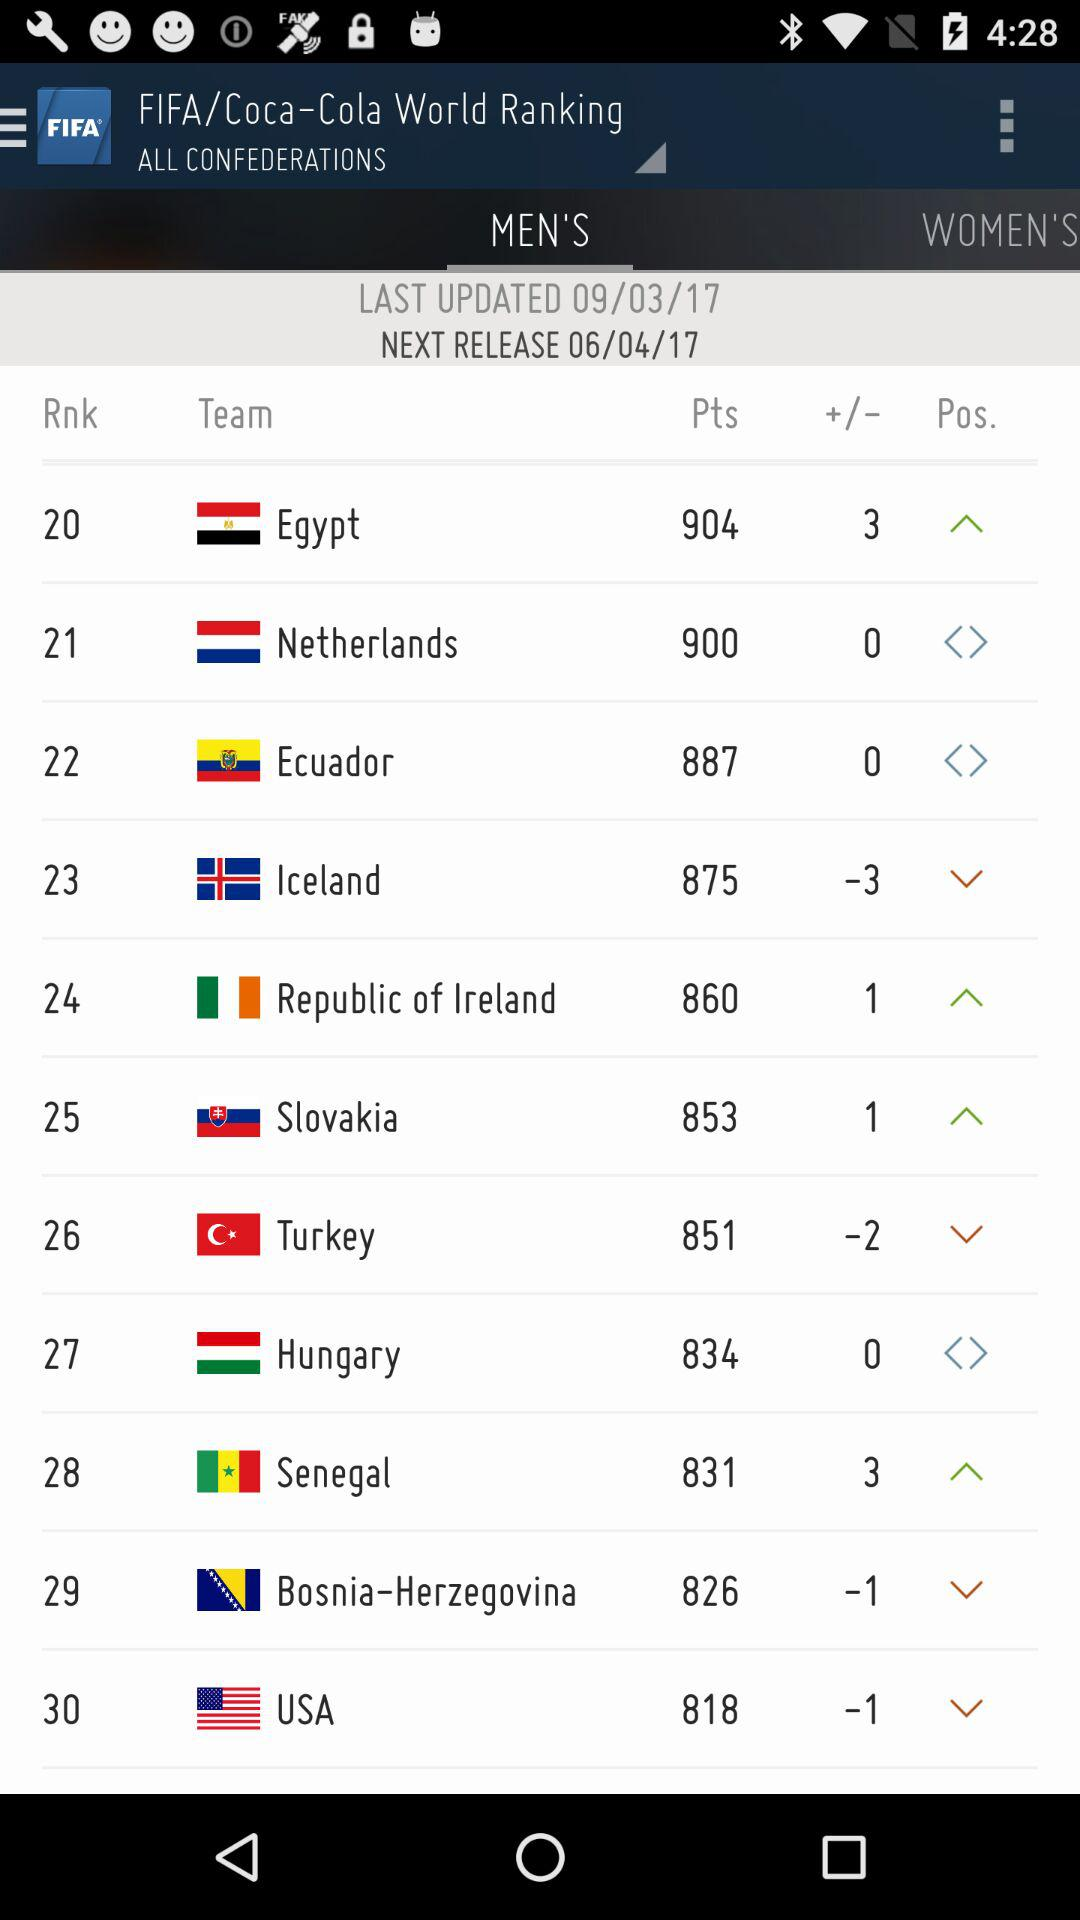How many points are there for team "USA"? The points are 818. 